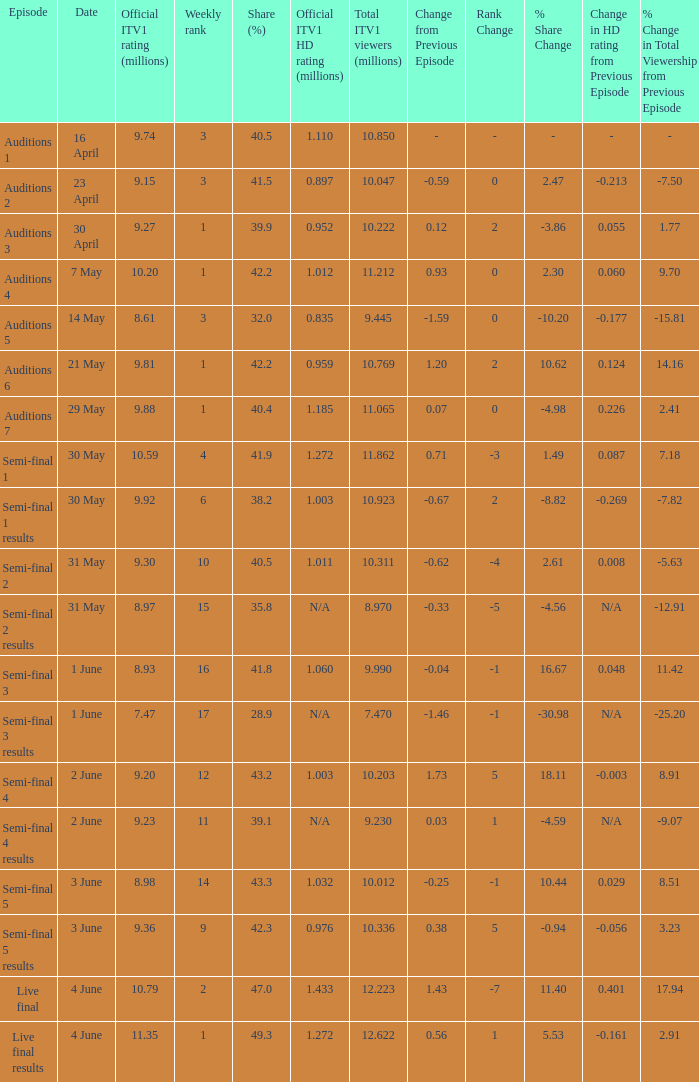What was the percentage share for the episode semi-final 2? 40.5. Help me parse the entirety of this table. {'header': ['Episode', 'Date', 'Official ITV1 rating (millions)', 'Weekly rank', 'Share (%)', 'Official ITV1 HD rating (millions)', 'Total ITV1 viewers (millions)', 'Change from Previous Episode', 'Rank Change', '% Share Change', 'Change in HD rating from Previous Episode', '% Change in Total Viewership from Previous Episode'], 'rows': [['Auditions 1', '16 April', '9.74', '3', '40.5', '1.110', '10.850', '-', '-', '-', '-', '-'], ['Auditions 2', '23 April', '9.15', '3', '41.5', '0.897', '10.047', '-0.59', '0', '2.47', '-0.213', '-7.50'], ['Auditions 3', '30 April', '9.27', '1', '39.9', '0.952', '10.222', '0.12', '2', '-3.86', '0.055', '1.77'], ['Auditions 4', '7 May', '10.20', '1', '42.2', '1.012', '11.212', '0.93', '0', '2.30', '0.060', '9.70'], ['Auditions 5', '14 May', '8.61', '3', '32.0', '0.835', '9.445', '-1.59', '0', '-10.20', '-0.177', '-15.81'], ['Auditions 6', '21 May', '9.81', '1', '42.2', '0.959', '10.769', '1.20', '2', '10.62', '0.124', '14.16'], ['Auditions 7', '29 May', '9.88', '1', '40.4', '1.185', '11.065', '0.07', '0', '-4.98', '0.226', '2.41'], ['Semi-final 1', '30 May', '10.59', '4', '41.9', '1.272', '11.862', '0.71', '-3', '1.49', '0.087', '7.18'], ['Semi-final 1 results', '30 May', '9.92', '6', '38.2', '1.003', '10.923', '-0.67', '2', '-8.82', '-0.269', '-7.82'], ['Semi-final 2', '31 May', '9.30', '10', '40.5', '1.011', '10.311', '-0.62', '-4', '2.61', '0.008', '-5.63'], ['Semi-final 2 results', '31 May', '8.97', '15', '35.8', 'N/A', '8.970', '-0.33', '-5', '-4.56', 'N/A', '-12.91'], ['Semi-final 3', '1 June', '8.93', '16', '41.8', '1.060', '9.990', '-0.04', '-1', '16.67', '0.048', '11.42'], ['Semi-final 3 results', '1 June', '7.47', '17', '28.9', 'N/A', '7.470', '-1.46', '-1', '-30.98', 'N/A', '-25.20'], ['Semi-final 4', '2 June', '9.20', '12', '43.2', '1.003', '10.203', '1.73', '5', '18.11', '-0.003', '8.91'], ['Semi-final 4 results', '2 June', '9.23', '11', '39.1', 'N/A', '9.230', '0.03', '1', '-4.59', 'N/A', '-9.07'], ['Semi-final 5', '3 June', '8.98', '14', '43.3', '1.032', '10.012', '-0.25', '-1', '10.44', '0.029', '8.51'], ['Semi-final 5 results', '3 June', '9.36', '9', '42.3', '0.976', '10.336', '0.38', '5', '-0.94', '-0.056', '3.23'], ['Live final', '4 June', '10.79', '2', '47.0', '1.433', '12.223', '1.43', '-7', '11.40', '0.401', '17.94'], ['Live final results', '4 June', '11.35', '1', '49.3', '1.272', '12.622', '0.56', '1', '5.53', '-0.161', '2.91']]} 